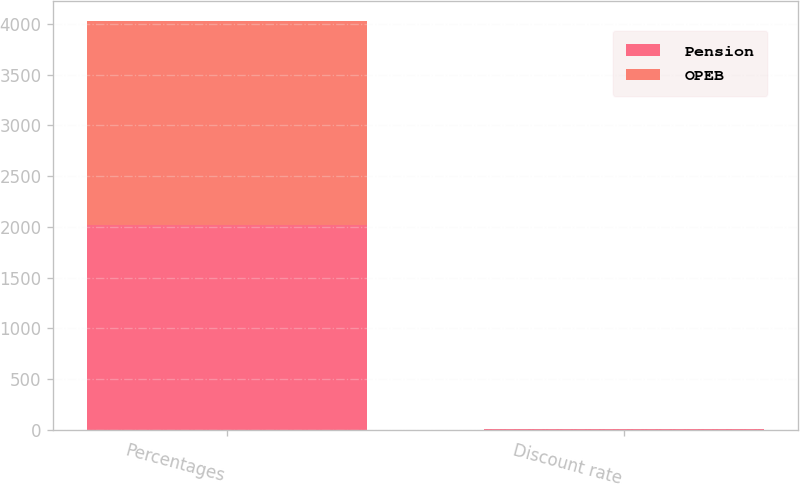Convert chart. <chart><loc_0><loc_0><loc_500><loc_500><stacked_bar_chart><ecel><fcel>Percentages<fcel>Discount rate<nl><fcel>Pension<fcel>2014<fcel>4.72<nl><fcel>OPEB<fcel>2014<fcel>4.47<nl></chart> 